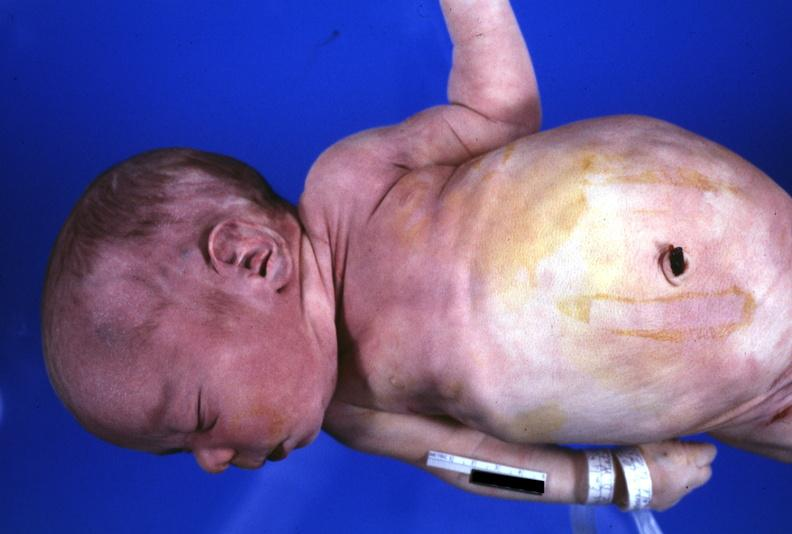does premature coronary disease show view of low set ears?
Answer the question using a single word or phrase. No 